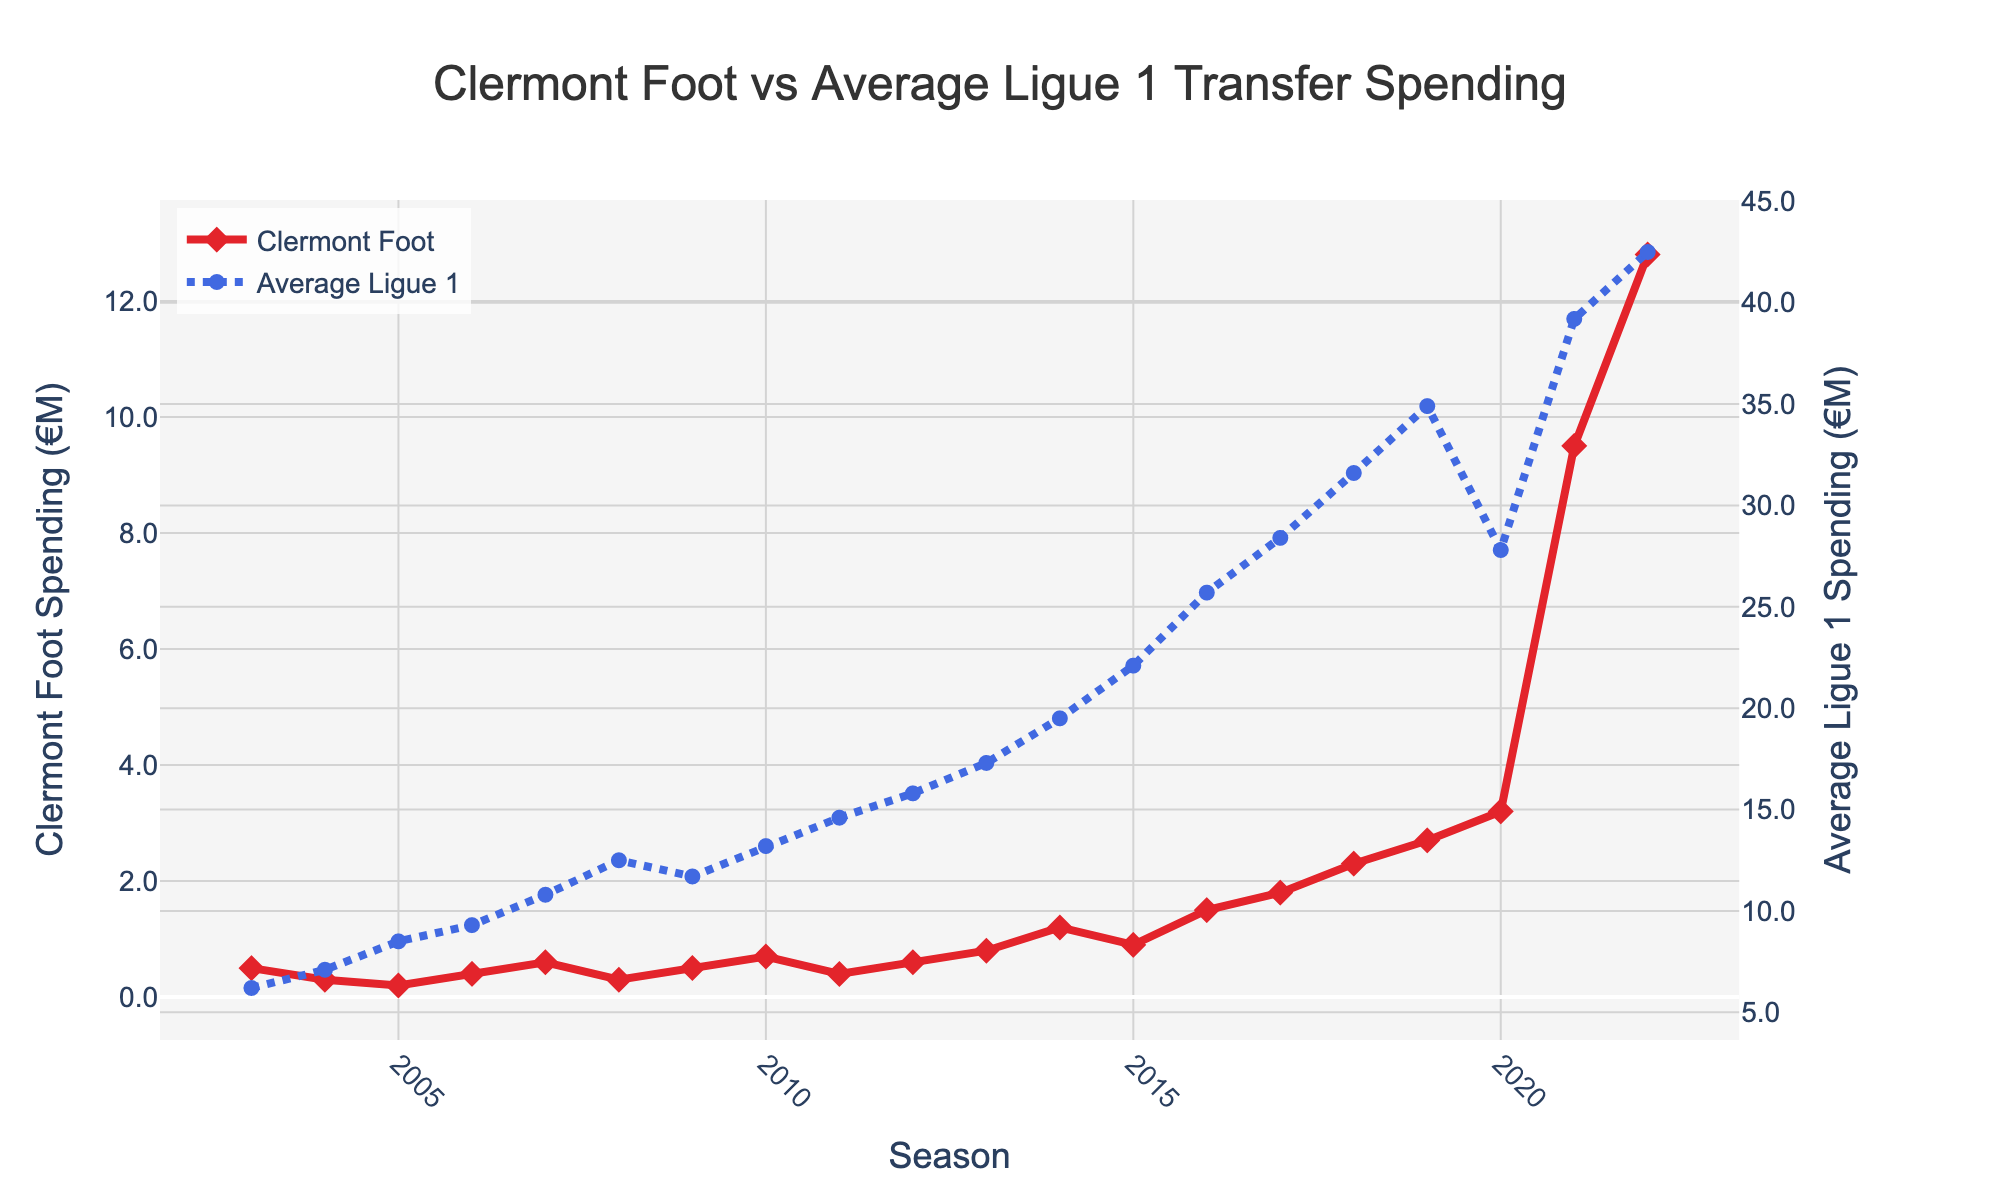What is the transfer spending of Clermont Foot in the 2015/16 season? Look for the point corresponding to the 2015/16 season on the red line representing Clermont Foot. The value is 0.9 million euros.
Answer: 0.9 million euros In which season did Clermont Foot have the highest transfer spending? Identify the highest point on the red line. The highest value is 12.8 million euros in the 2022/23 season.
Answer: 2022/23 What is the average transfer spending of Clermont Foot over the 20 years? Sum all the transfer spending values of Clermont Foot and divide by 20. (0.5 + 0.3 + 0.2 + 0.4 + 0.6 + 0.3 + 0.5 + 0.7 + 0.4 + 0.6 + 0.8 + 1.2 + 0.9 + 1.5 + 1.8 + 2.3 + 2.7 + 3.2 + 9.5 + 12.8) / 20 = 2.17 million euros.
Answer: 2.17 million euros How does the Clermont Foot transfer spending in 2020/21 compare to the average Ligue 1 spending in the same season? Compare the values of the red and blue lines for the 2020/21 season. Clermont Foot spent 3.2 million euros, while the average Ligue 1 spending was 27.8 million euros.
Answer: Less than What is the difference between Clermont Foot's spending and the average Ligue 1 spending in 2022/23? Subtract Clermont Foot's spending of 12.8 million euros from the average Ligue 1 spending of 42.5 million euros in 2022/23. 42.5 - 12.8 = 29.7 million euros.
Answer: 29.7 million euros Which season had the smallest difference between Clermont Foot's spending and the average Ligue 1 spending? Calculate the differences for each season and identify the smallest one. The smallest difference occurs in the 2008/09 season with (12.5 - 0.3) = 12.2 million euros.
Answer: 2008/09 In which seasons did Clermont Foot's transfer spending increase compared to the previous season? Identify the seasons where the red line trends upwards. The seasons are 2007/08, 2010/11, 2012/13, 2013/14, 2014/15, 2016/17, 2017/18, 2018/19, 2019/20, 2020/21, 2021/22, and 2022/23.
Answer: 2007/08, 2010/11, 2012/13, 2013/14, 2014/15, 2016/17, 2017/18, 2018/19, 2019/20, 2020/21, 2021/22, 2022/23 How much did Clermont Foot's transfer spending increase from 2020/21 to 2021/22? Subtract the transfer spending in 2020/21 from 2021/22: 9.5 - 3.2 = 6.3 million euros.
Answer: 6.3 million euros What is the trend of the average Ligue 1 transfer spending from 2003/04 to 2022/23? Observe the blue dotted line. It shows a general upward trend over the 20 years.
Answer: Upward 